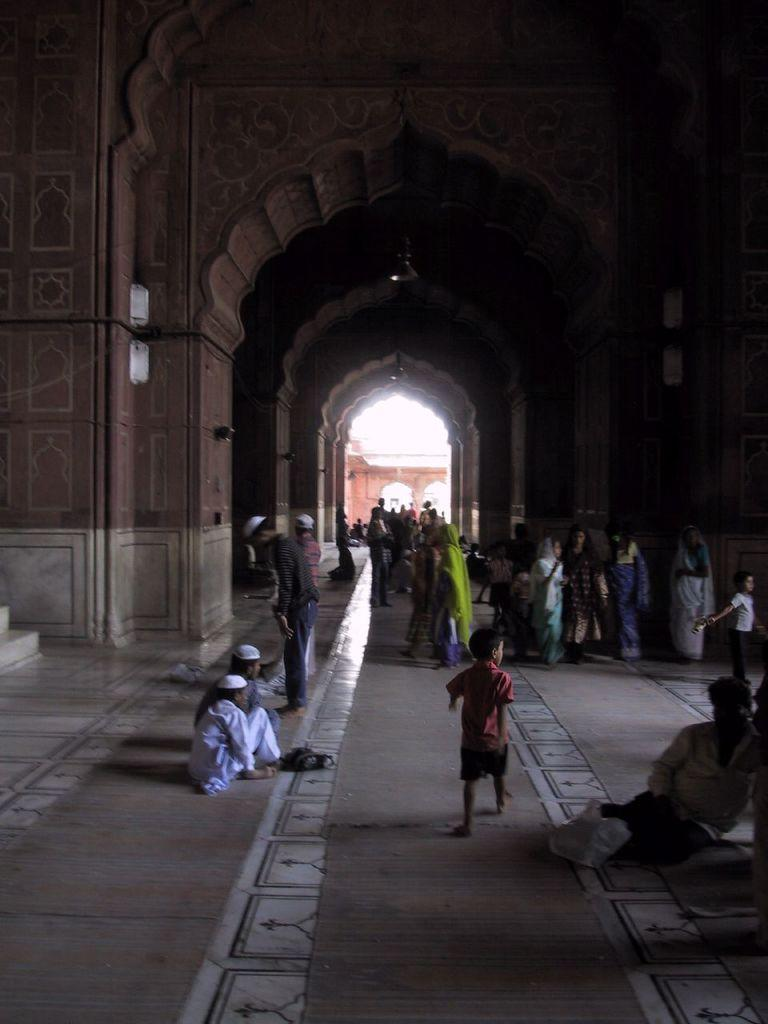What type of building is shown in the image? The image depicts the interior of a mosque. Can you describe the setting of the image? The image shows the interior of a mosque, which typically includes prayer halls and other religious spaces. How many people are present in the image? There are many people in the image. What type of bear can be seen tending to a wound in the image? There is no bear or wound present in the image; it depicts the interior of a mosque with many people. 